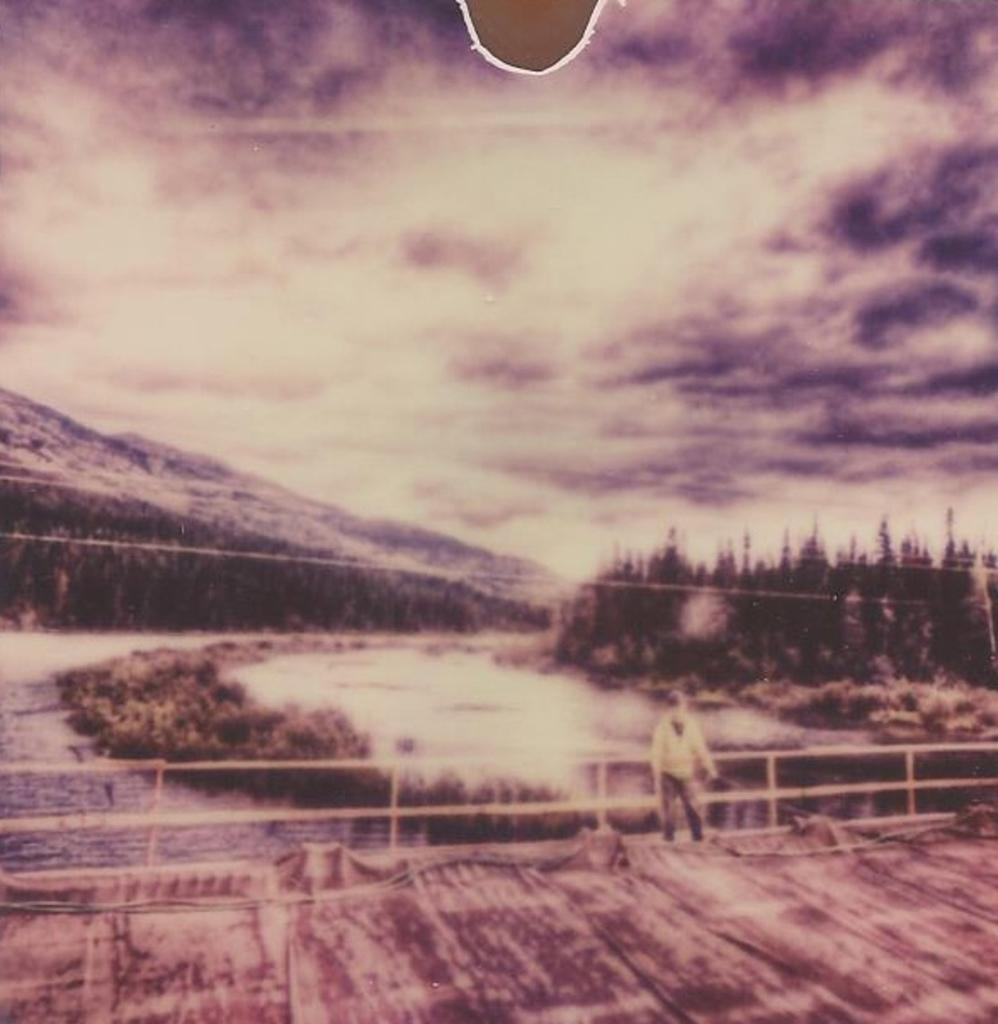What is the main subject of the image? There is a person standing in the image. What structure can be seen in the image? There is a bridge in the image. What natural element is visible in the image? There is water visible in the image. What type of vegetation is present in the image? There are trees in the image. What type of landscape feature is present in the image? There is a hill in the image. What is visible in the background of the image? The sky is visible in the image. What color crayon is being used to draw the alley in the image? There is no alley or crayon present in the image. 